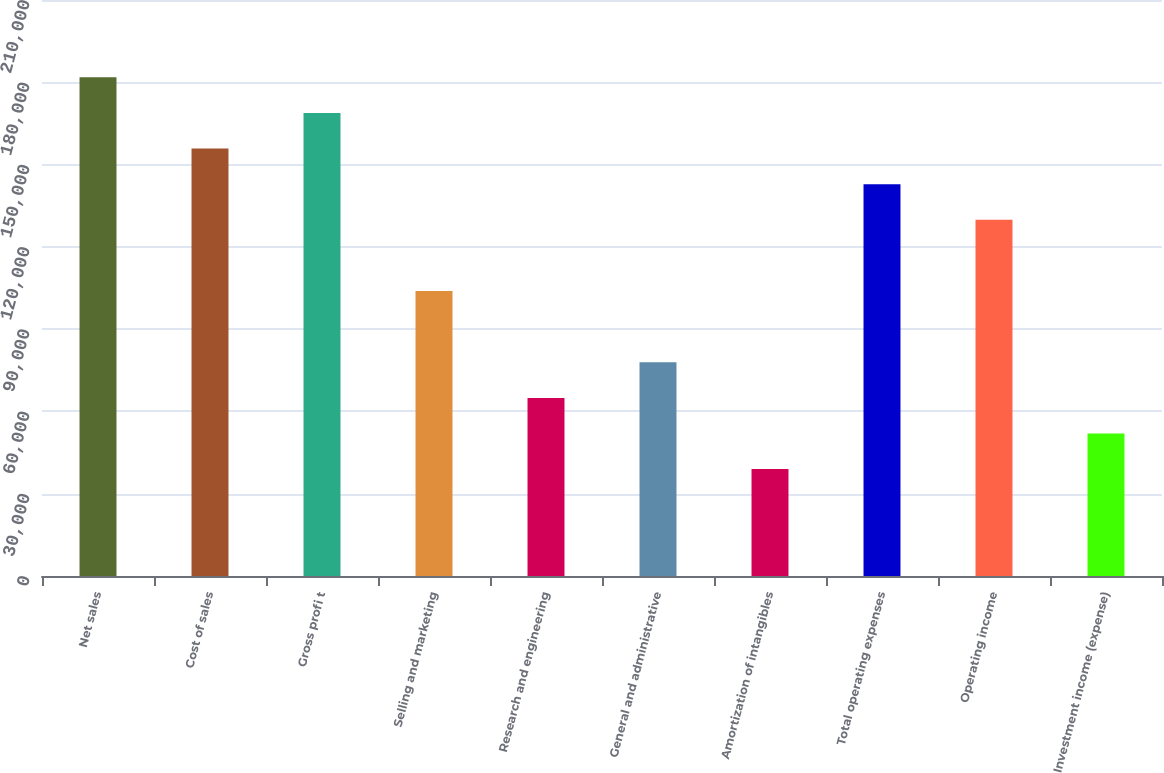<chart> <loc_0><loc_0><loc_500><loc_500><bar_chart><fcel>Net sales<fcel>Cost of sales<fcel>Gross profi t<fcel>Selling and marketing<fcel>Research and engineering<fcel>General and administrative<fcel>Amortization of intangibles<fcel>Total operating expenses<fcel>Operating income<fcel>Investment income (expense)<nl><fcel>181803<fcel>155833<fcel>168818<fcel>103893<fcel>64938.5<fcel>77923.4<fcel>38968.7<fcel>142848<fcel>129863<fcel>51953.6<nl></chart> 